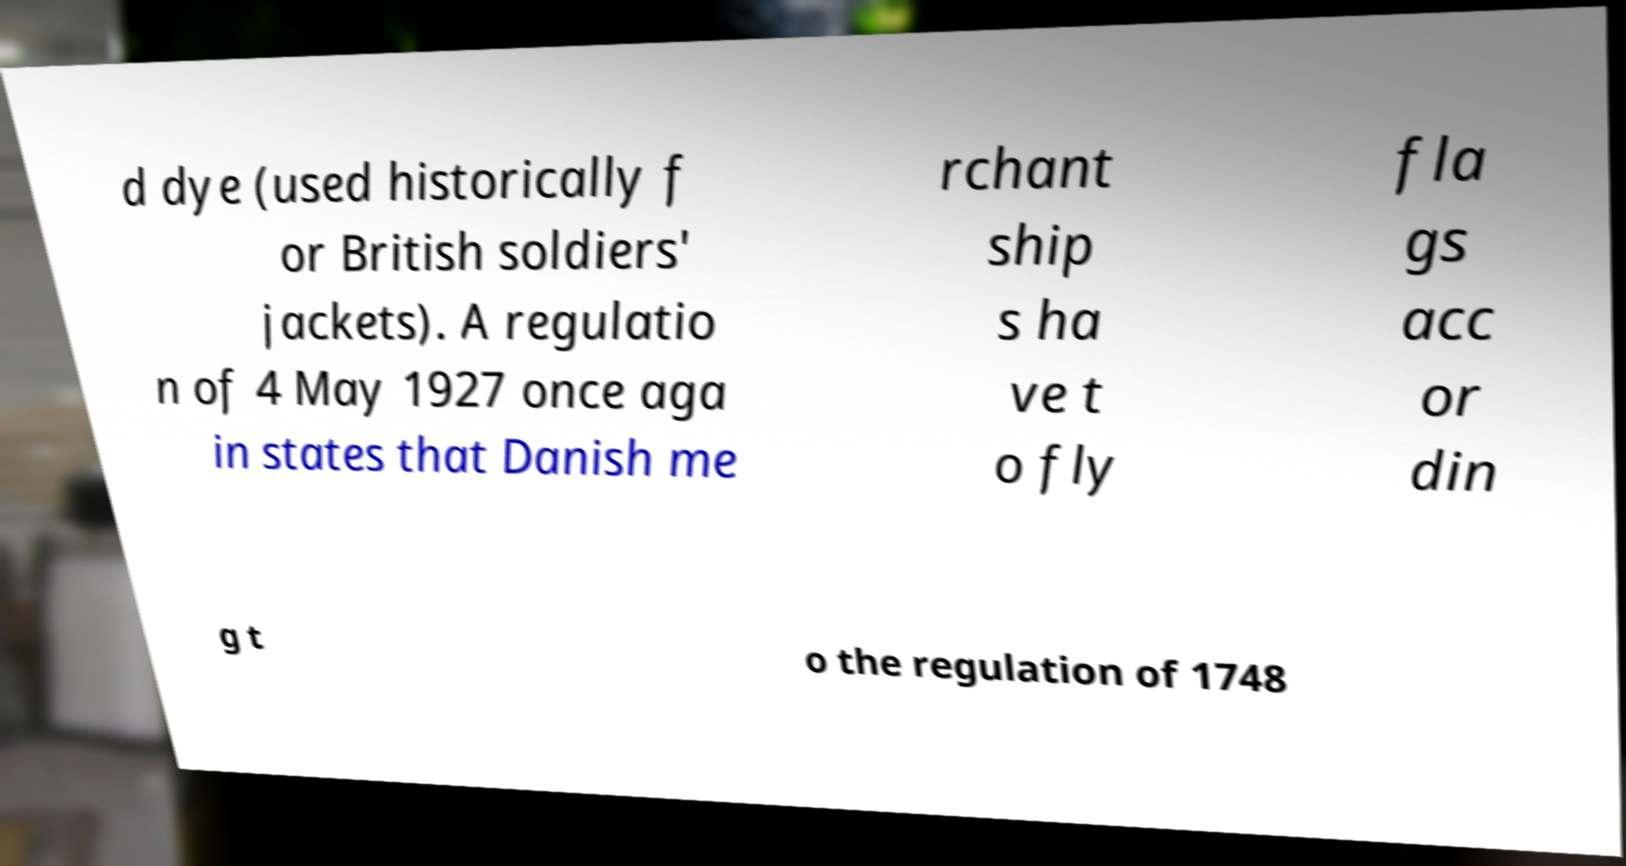There's text embedded in this image that I need extracted. Can you transcribe it verbatim? d dye (used historically f or British soldiers' jackets). A regulatio n of 4 May 1927 once aga in states that Danish me rchant ship s ha ve t o fly fla gs acc or din g t o the regulation of 1748 